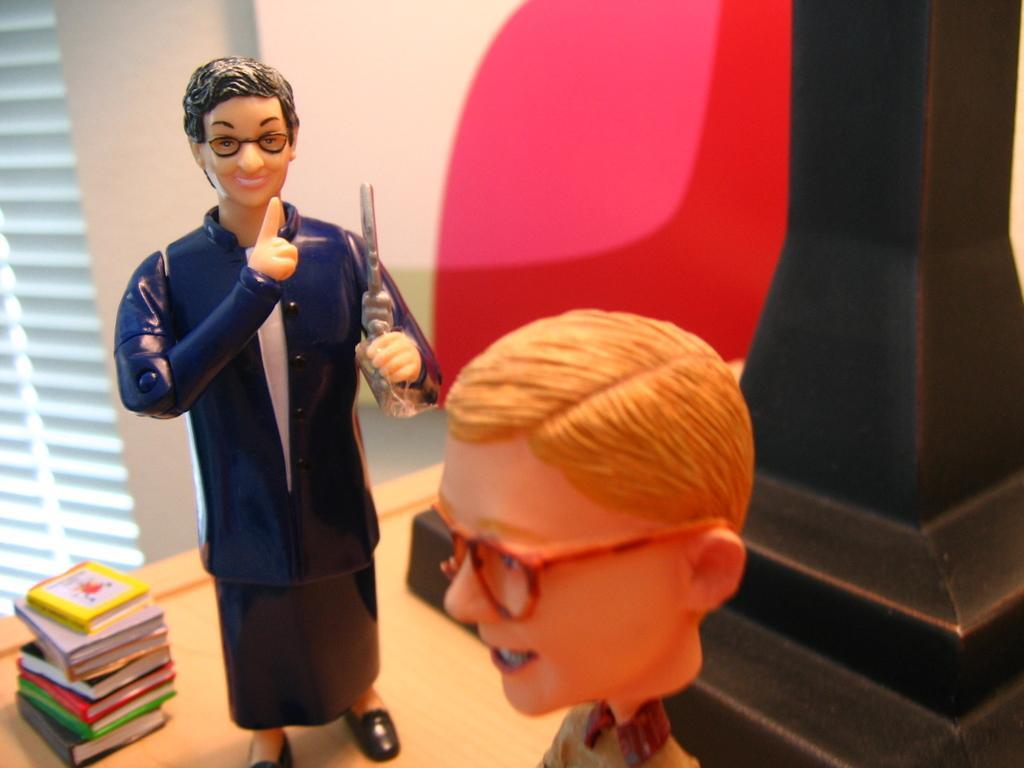Can you describe this image briefly? In this image we can see toys placed on the table. On the left side of the image we can see books and window. In the background there is wall. 